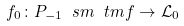Convert formula to latex. <formula><loc_0><loc_0><loc_500><loc_500>f _ { 0 } \colon P _ { - 1 } \ s m \ t m f \to \mathcal { L } _ { 0 }</formula> 